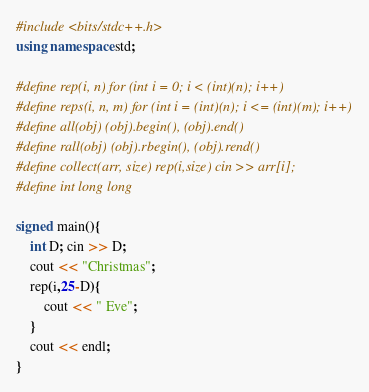<code> <loc_0><loc_0><loc_500><loc_500><_C++_>#include <bits/stdc++.h>
using namespace std;

#define rep(i, n) for (int i = 0; i < (int)(n); i++)
#define reps(i, n, m) for (int i = (int)(n); i <= (int)(m); i++)
#define all(obj) (obj).begin(), (obj).end()
#define rall(obj) (obj).rbegin(), (obj).rend()
#define collect(arr, size) rep(i,size) cin >> arr[i];
#define int long long

signed main(){
    int D; cin >> D;
    cout << "Christmas";
    rep(i,25-D){
        cout << " Eve";
    }
    cout << endl;
}</code> 